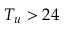Convert formula to latex. <formula><loc_0><loc_0><loc_500><loc_500>T _ { u } > 2 4</formula> 